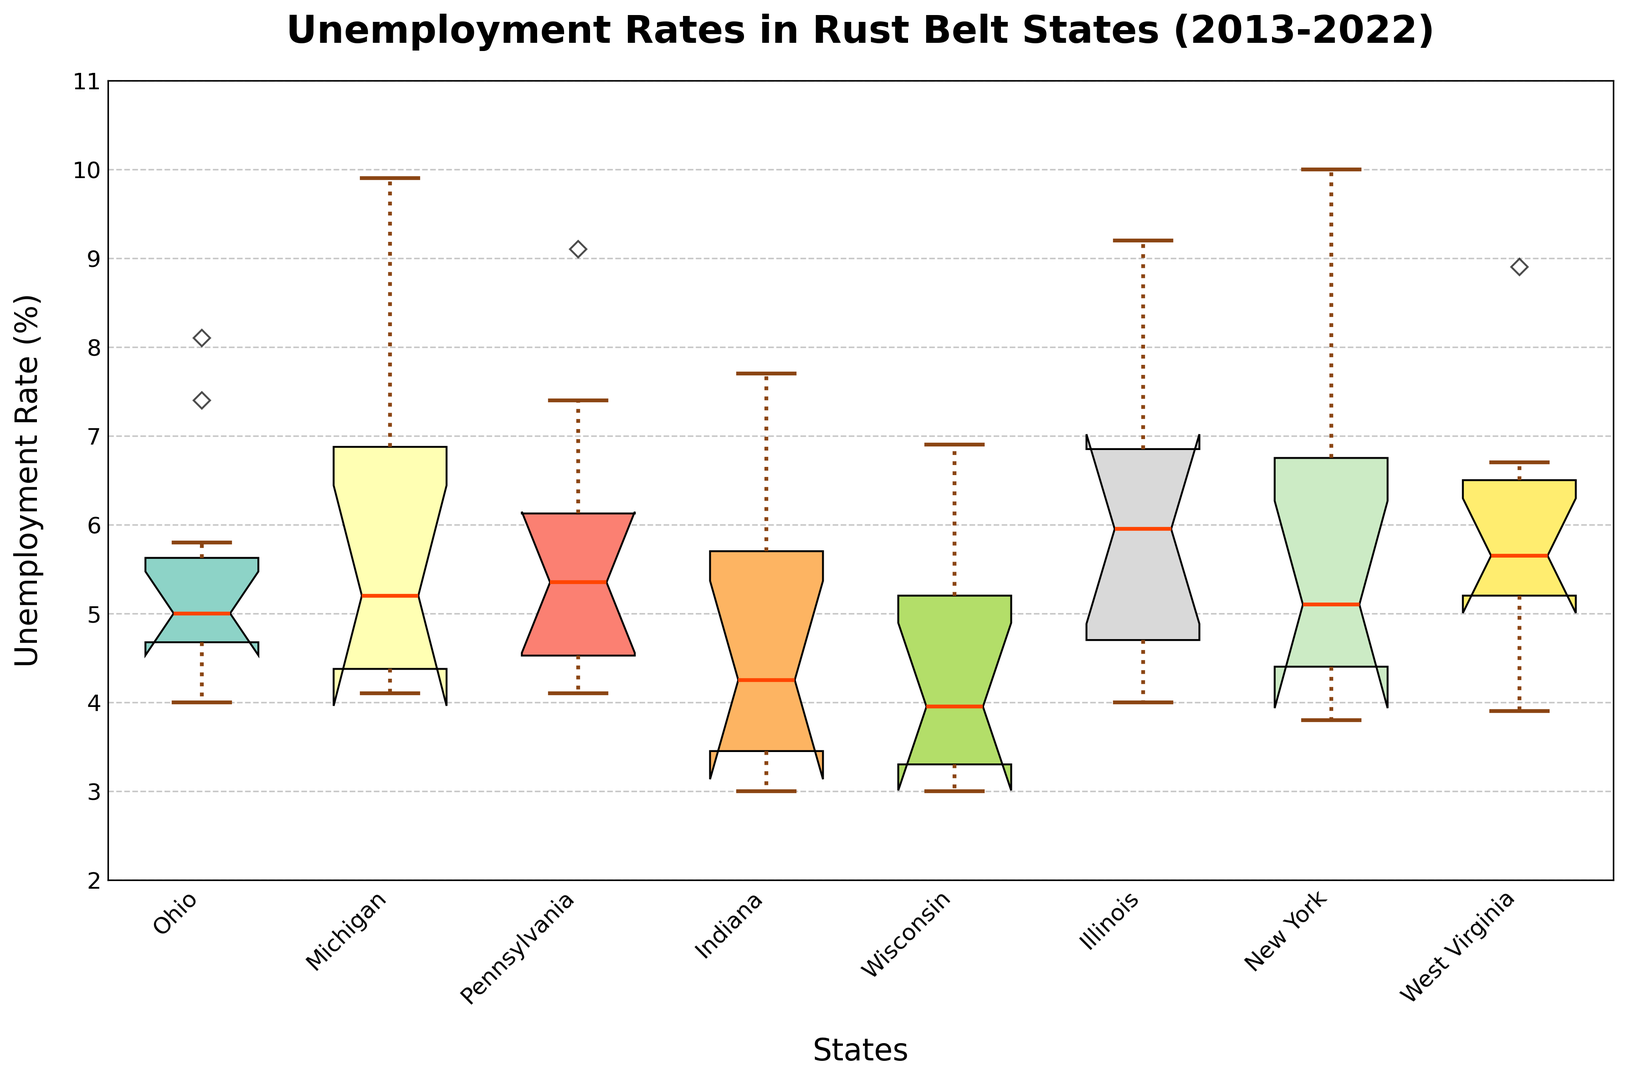What's the median unemployment rate for Ohio? We look at the middle value of the box for Ohio to find the median. The boxplot's Ohio median line is around the 5.0 mark on the y-axis.
Answer: 5.0 Which state had the highest maximum unemployment rate, and what was it? The whisker at the top of the boxplot indicates the maximum value. New York's whisker extends the highest, reaching the 10.0 mark.
Answer: New York, 10.0 What's the difference between the median unemployment rates of Indiana and Illinois? To find the difference, subtract Illinois's median value (5.0) from Indiana's median value (3.5).
Answer: 1.5 Which state has the lowest minimum unemployment rate, and what's the value? The whisker at the bottom of the boxplot indicates the minimum value. Indiana's bottom whisker is at 3.0, which is the lowest.
Answer: Indiana, 3.0 Compare the variation in unemployment rates between Michigan and Wisconsin. Which state has greater variation? Variation is seen by looking at the height of the boxes and the whiskers. Michigan's box is taller and its whiskers are longer compared to Wisconsin, indicating higher variation in Michigan.
Answer: Michigan Among all the states, which one has the lowest median unemployment rate, and what is the value? Examine the middle line of each box to find the lowest median. Indiana's median line is at 3.5, which is the lowest.
Answer: Indiana, 3.5 How does the upper quartile (75th percentile) of Pennsylvania compare to Ohio's? The upper quartile is at the top of each box. Pennsylvania's upper quartile is higher than Ohio's, around 6.5 compared to Ohio's roughly 6.0.
Answer: Pennsylvania is higher Which states' unemployment rates have IQR's ranging from 4.0 to 5.0? The Interquartile Range (IQR) is the height of the boxes. Examine the boxes and identify which states' boxes fall between these values. Illinois's box fits this range.
Answer: Illinois What year had the highest unemployment rate for Pennsylvania, and what was it? This requires looking at the whisker and its components. The highest rate for Pennsylvania is 9.1, occurring in 2020.
Answer: 2020, 9.1 Comparing Ohio and New York, which has more outliers, and how many? Outliers in a boxplot are marked by distinct points outside the whiskers. New York has more visible outliers compared to Ohio. New York has around three outliers, while Ohio has one.
Answer: New York, 3 